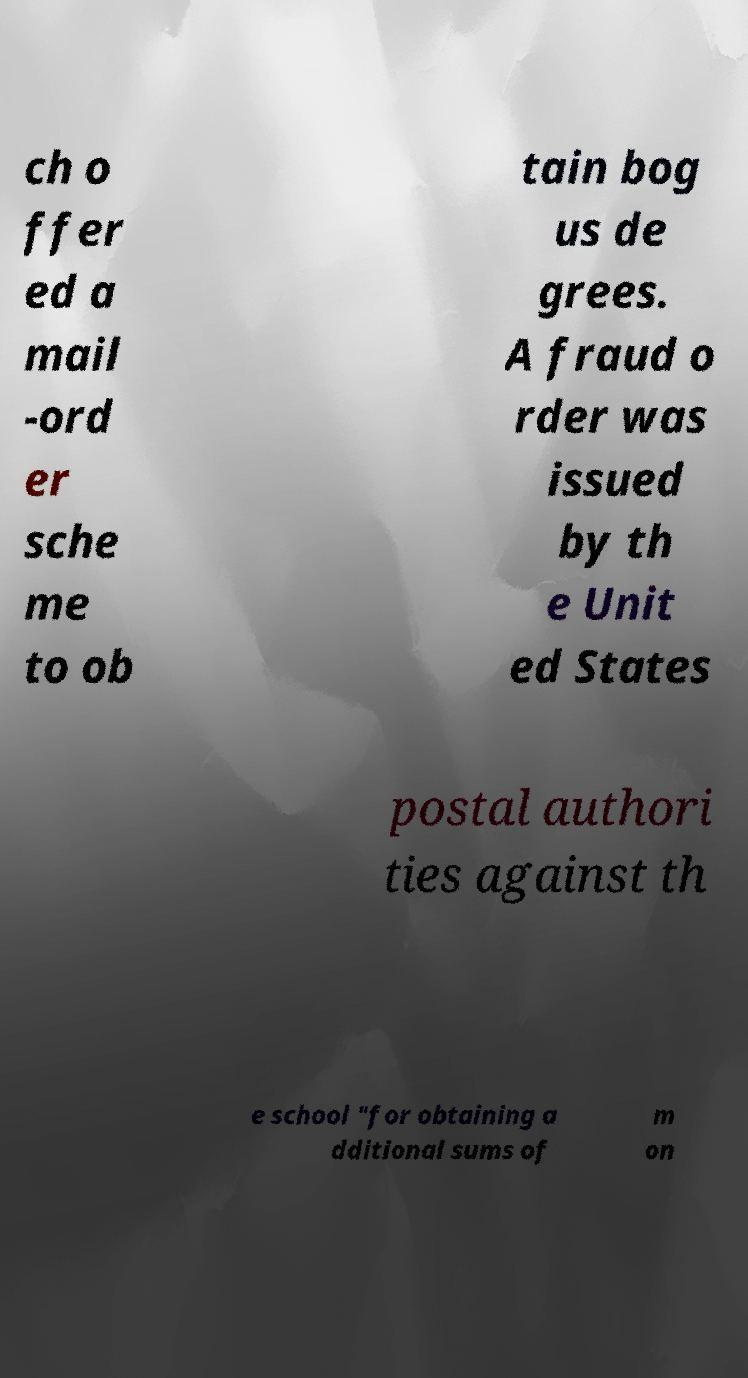Please identify and transcribe the text found in this image. ch o ffer ed a mail -ord er sche me to ob tain bog us de grees. A fraud o rder was issued by th e Unit ed States postal authori ties against th e school "for obtaining a dditional sums of m on 